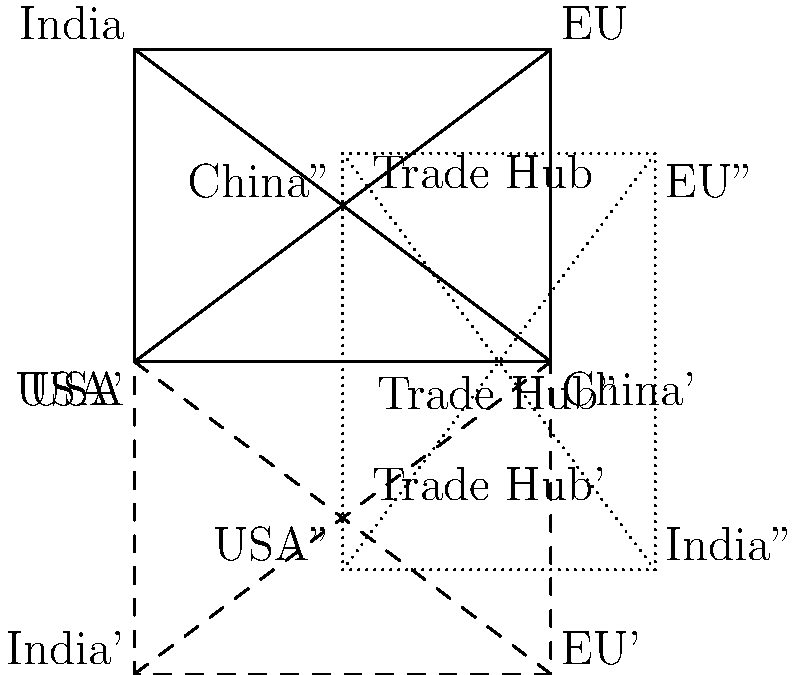In a diagram representing international trade routes, the original positions of the USA, China, EU, India, and a central Trade Hub are shown. The diagram undergoes two transformations: first, a reflection across the line connecting the USA and China, followed by a 90-degree clockwise rotation around the midpoint between the USA and China. After these transformations, what is the new position of the EU relative to its original position? Let's break this down step-by-step:

1) The original position of the EU is in the upper right corner of the rectangle.

2) First transformation - Reflection:
   - The EU is reflected across the line connecting the USA and China (the base of the rectangle).
   - This moves the EU to the lower right corner of the reflected (dashed) rectangle.

3) Second transformation - Rotation:
   - The reflected diagram is then rotated 90 degrees clockwise around the midpoint between the USA and China.
   - This point of rotation is the center of the base of the original rectangle.

4) After rotation:
   - The EU moves from the lower right corner to the lower left corner of the dotted rectangle.

5) Comparing final and original positions:
   - The EU started in the upper right corner.
   - It ended in the lower left corner.
   - Relative to its original position, it has moved diagonally across the rectangle.

6) In geometric terms:
   - This diagonal movement is equivalent to a 180-degree rotation around the center of the original rectangle.
Answer: 180-degree rotation around the center of the original rectangle 